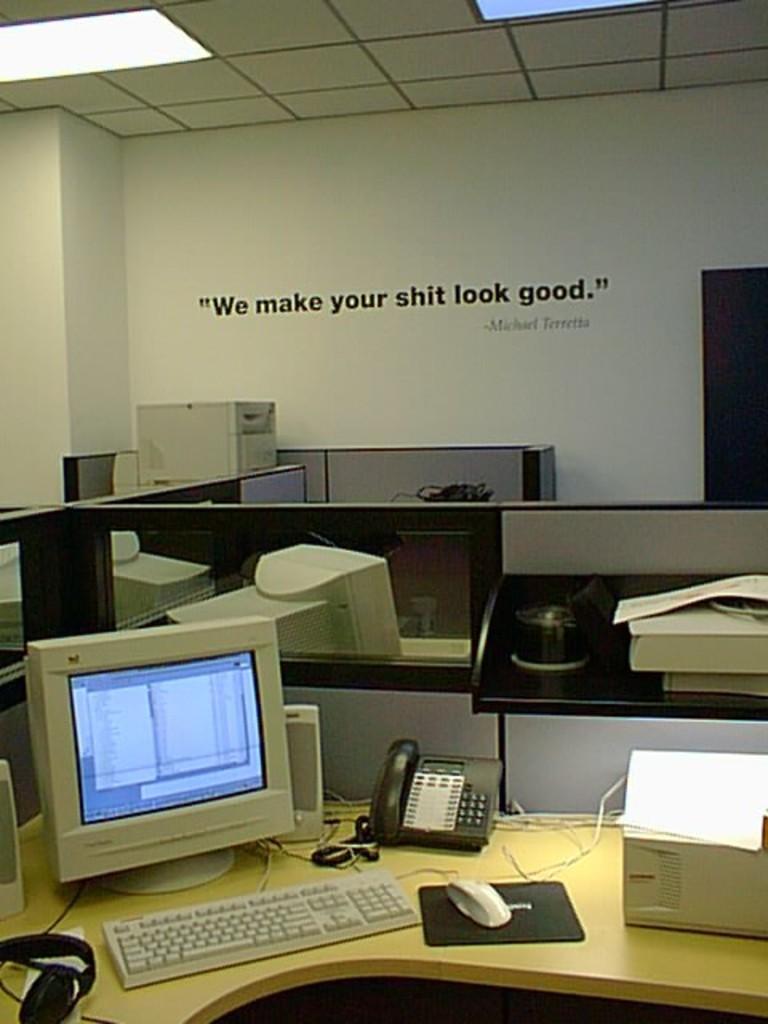How would you summarize this image in a sentence or two? This looking like a office. There are monitors , keyboard, mouse,phone on the desk. In the room there are partitions. on the wall it is written ¨We make your shit look good.¨ 